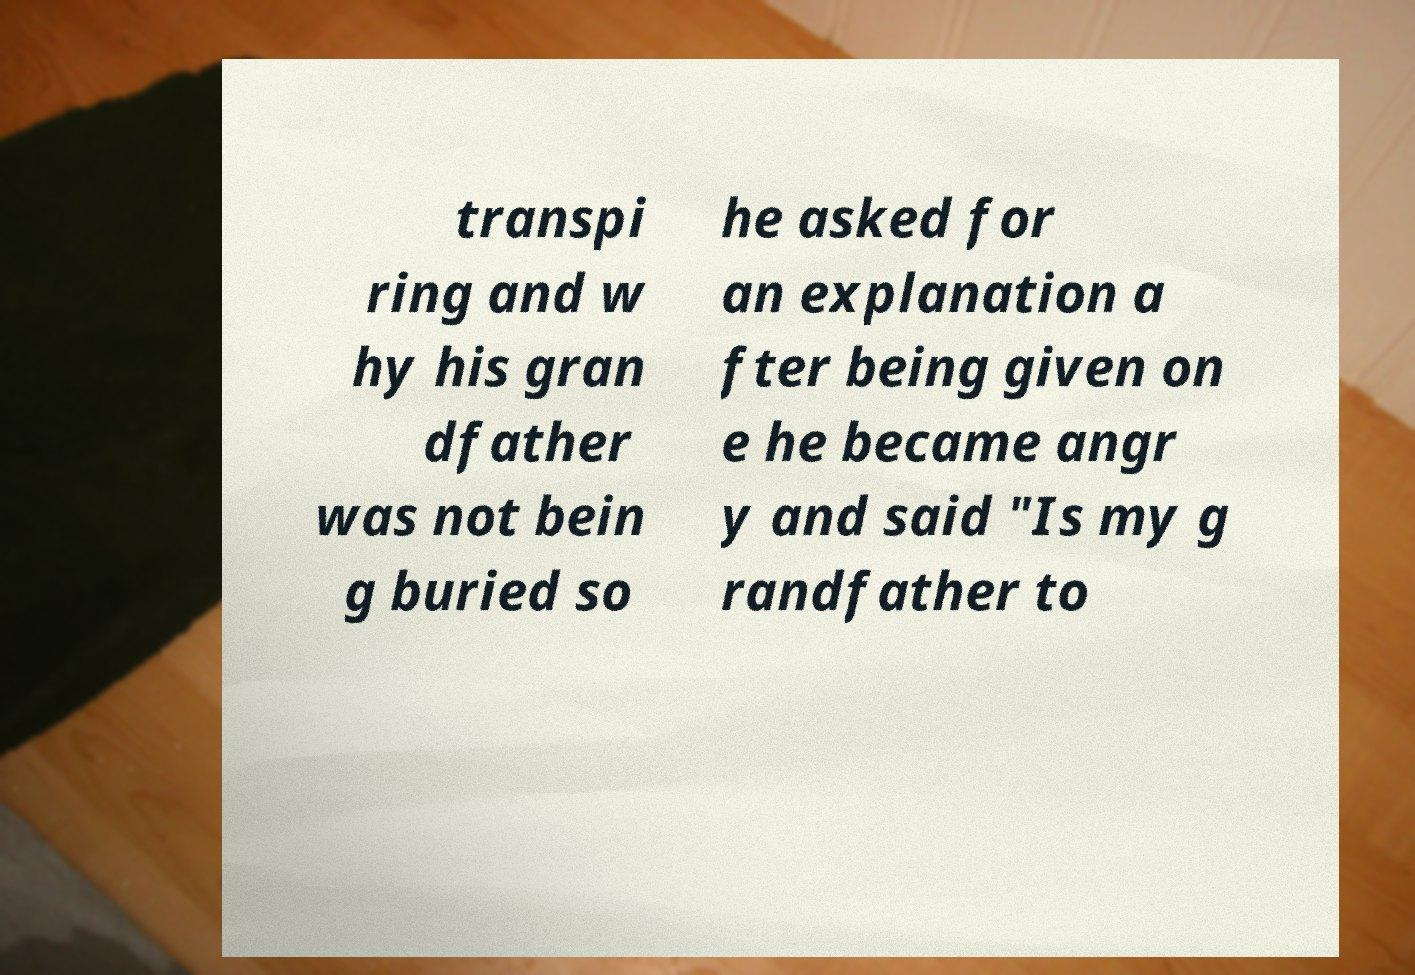Could you assist in decoding the text presented in this image and type it out clearly? transpi ring and w hy his gran dfather was not bein g buried so he asked for an explanation a fter being given on e he became angr y and said "Is my g randfather to 